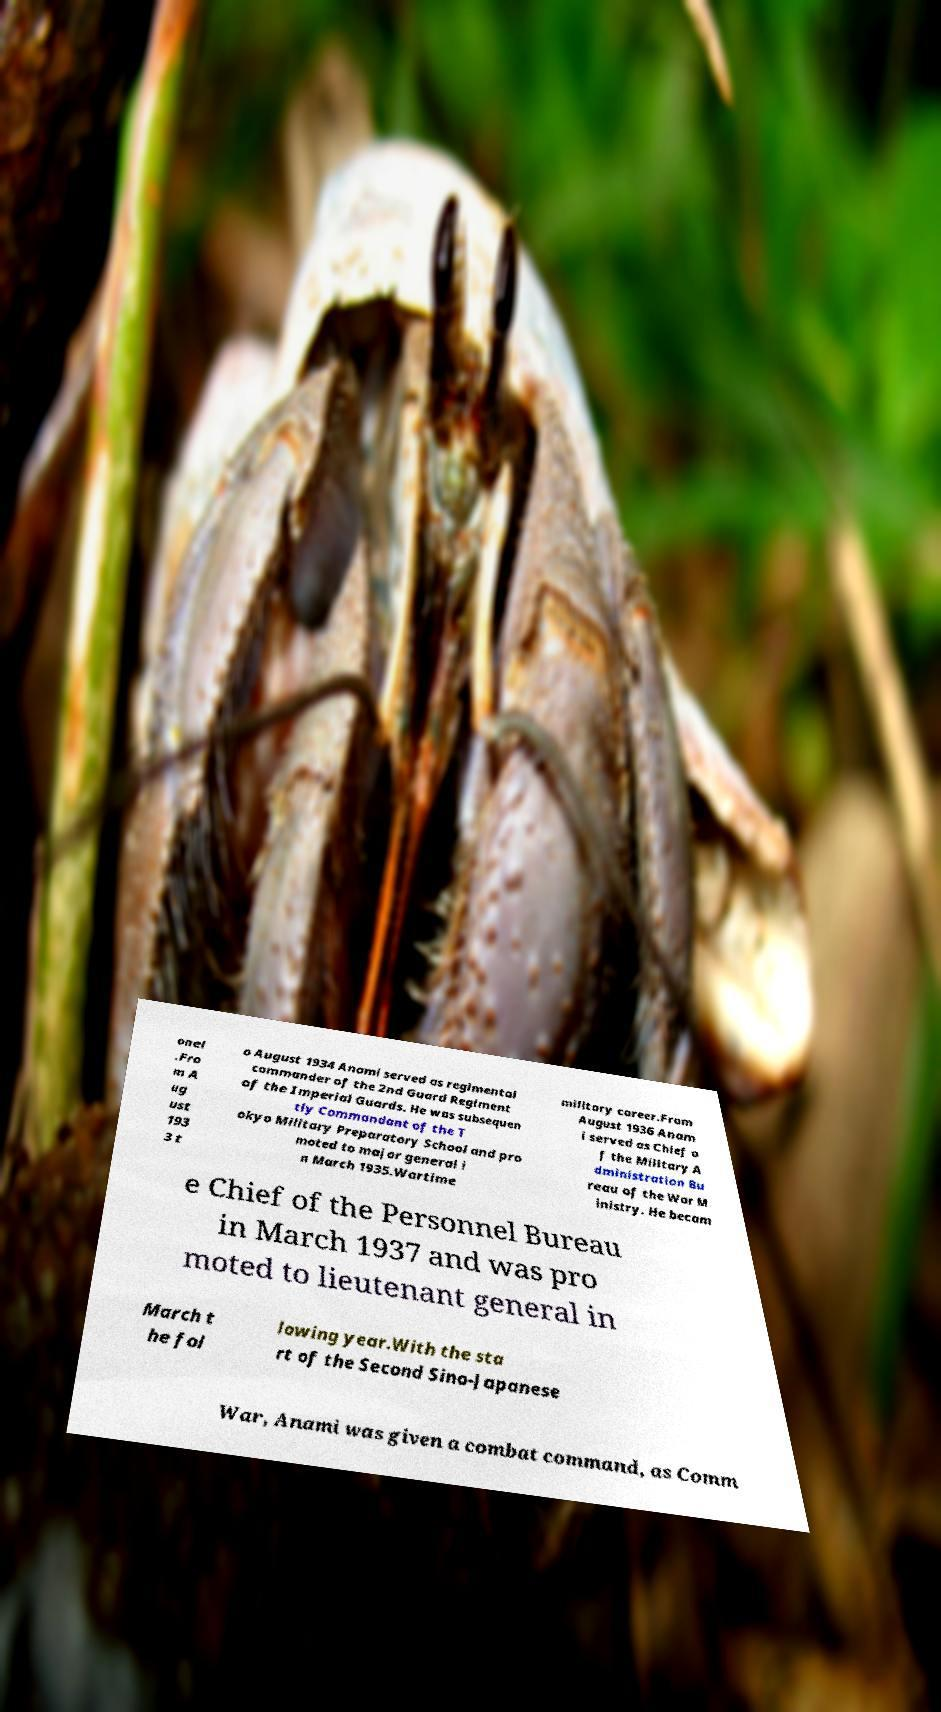Please identify and transcribe the text found in this image. onel .Fro m A ug ust 193 3 t o August 1934 Anami served as regimental commander of the 2nd Guard Regiment of the Imperial Guards. He was subsequen tly Commandant of the T okyo Military Preparatory School and pro moted to major general i n March 1935.Wartime military career.From August 1936 Anam i served as Chief o f the Military A dministration Bu reau of the War M inistry. He becam e Chief of the Personnel Bureau in March 1937 and was pro moted to lieutenant general in March t he fol lowing year.With the sta rt of the Second Sino-Japanese War, Anami was given a combat command, as Comm 